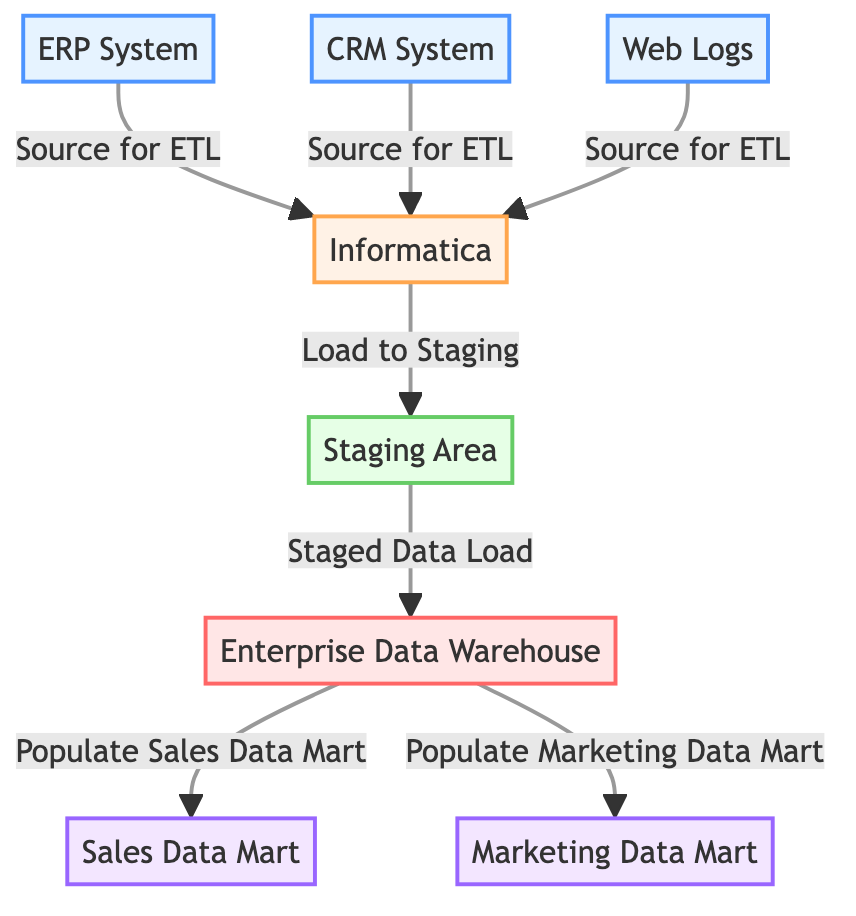What are the source systems in the ETL process? The diagram indicates that there are three source systems: ERP System, CRM System, and Web Logs. These systems provide data for the ETL process.
Answer: ERP System, CRM System, Web Logs How many data marts are shown in the diagram? The diagram displays two data marts: Sales Data Mart and Marketing Data Mart. These are the objects where the data gets processed further for specific business segments.
Answer: 2 What tool is used for the ETL process? According to the diagram, the ETL tool used is Informatica. This tool carries out the extraction, transformation, and loading of the data into the staging area.
Answer: Informatica What is the relationship between the Staging Area and the Enterprise Data Warehouse? The Staging Area sends staged data to the Enterprise Data Warehouse, as indicated by the arrow that connects these two components in the diagram, meaning that data is loaded into the warehouse after being staged.
Answer: Staged Data Load Which source system is not categorized under customer-related data? Based on the information presented in the diagram, the source system Web Logs is not categorized as customer-related data when compared to the ERP and CRM systems, which are centered around customer information and interactions.
Answer: Web Logs After data is loaded to the Staging Area, where does it go next? The next step after data is loaded to the Staging Area is that it is transferred to the Enterprise Data Warehouse, highlighting the sequential flow of the ETL process after staging.
Answer: Enterprise Data Warehouse How many nodes represent data processing areas in the ETL workflow? In the diagram, there are three nodes that represent data processing areas: Staging Area, Enterprise Data Warehouse, and the two Data Marts. These nodes focus on handling and structuring data for analysis and reporting.
Answer: 4 Which systems provide data as input to the ETL tool? The systems that provide data to the ETL tool Informatica are indicated as inputs are the ERP System, CRM System, and Web Logs, all of which supply essential data for further processing.
Answer: ERP System, CRM System, Web Logs 